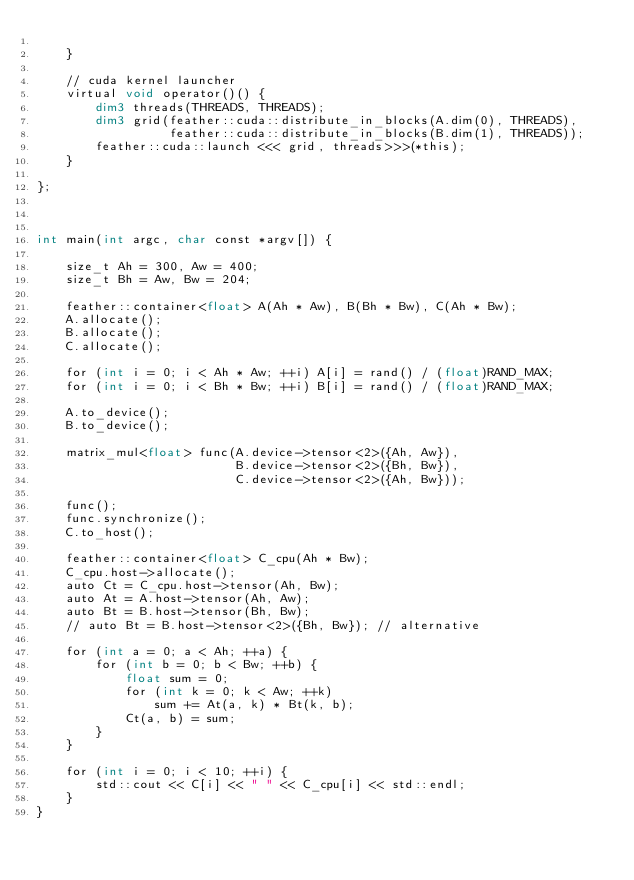<code> <loc_0><loc_0><loc_500><loc_500><_Cuda_>
    }

    // cuda kernel launcher
    virtual void operator()() {
        dim3 threads(THREADS, THREADS);
        dim3 grid(feather::cuda::distribute_in_blocks(A.dim(0), THREADS),
                  feather::cuda::distribute_in_blocks(B.dim(1), THREADS));
        feather::cuda::launch <<< grid, threads>>>(*this);
    }

};



int main(int argc, char const *argv[]) {

    size_t Ah = 300, Aw = 400;
    size_t Bh = Aw, Bw = 204;

    feather::container<float> A(Ah * Aw), B(Bh * Bw), C(Ah * Bw); 
    A.allocate();
    B.allocate();
    C.allocate();

    for (int i = 0; i < Ah * Aw; ++i) A[i] = rand() / (float)RAND_MAX;
    for (int i = 0; i < Bh * Bw; ++i) B[i] = rand() / (float)RAND_MAX;

    A.to_device();
    B.to_device();

    matrix_mul<float> func(A.device->tensor<2>({Ah, Aw}), 
                           B.device->tensor<2>({Bh, Bw}),
                           C.device->tensor<2>({Ah, Bw}));

    func();
    func.synchronize();
    C.to_host();

    feather::container<float> C_cpu(Ah * Bw); 
    C_cpu.host->allocate();
    auto Ct = C_cpu.host->tensor(Ah, Bw);
    auto At = A.host->tensor(Ah, Aw);
    auto Bt = B.host->tensor(Bh, Bw);
    // auto Bt = B.host->tensor<2>({Bh, Bw}); // alternative

    for (int a = 0; a < Ah; ++a) {
        for (int b = 0; b < Bw; ++b) {
            float sum = 0;
            for (int k = 0; k < Aw; ++k)
                sum += At(a, k) * Bt(k, b);
            Ct(a, b) = sum;
        }
    }

    for (int i = 0; i < 10; ++i) {
        std::cout << C[i] << " " << C_cpu[i] << std::endl;
    }
}
</code> 